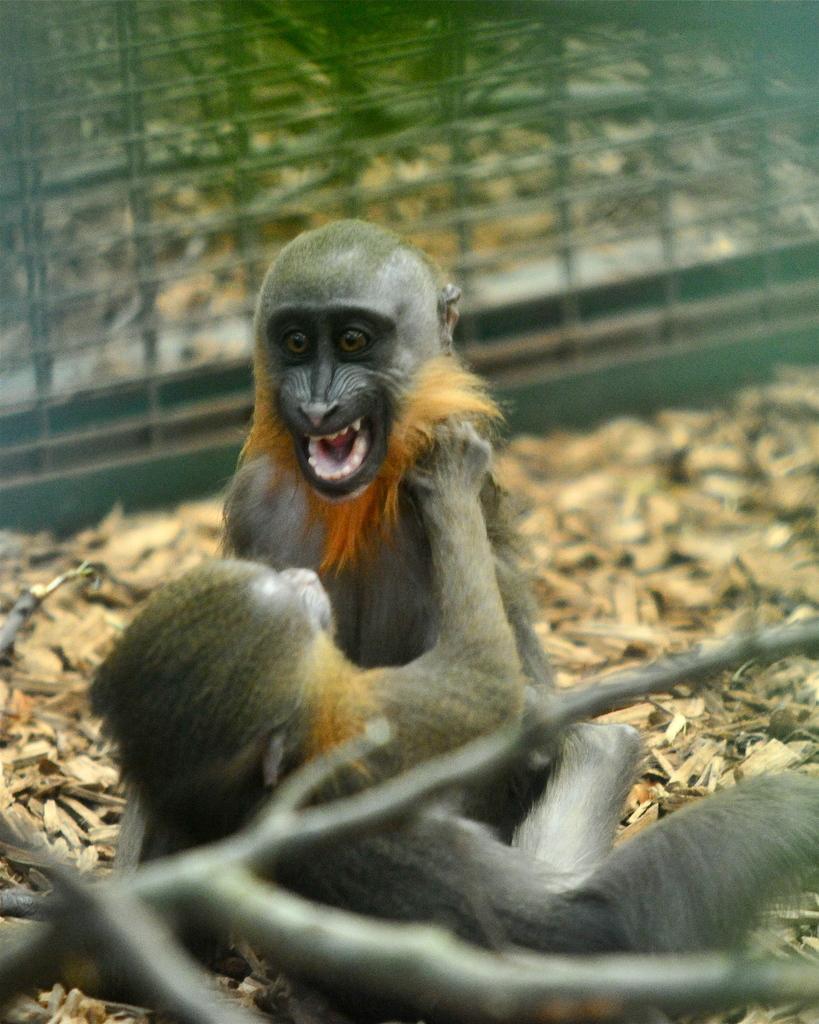How would you summarize this image in a sentence or two? In this picture we can see monkeys, in the background we can find fence. 